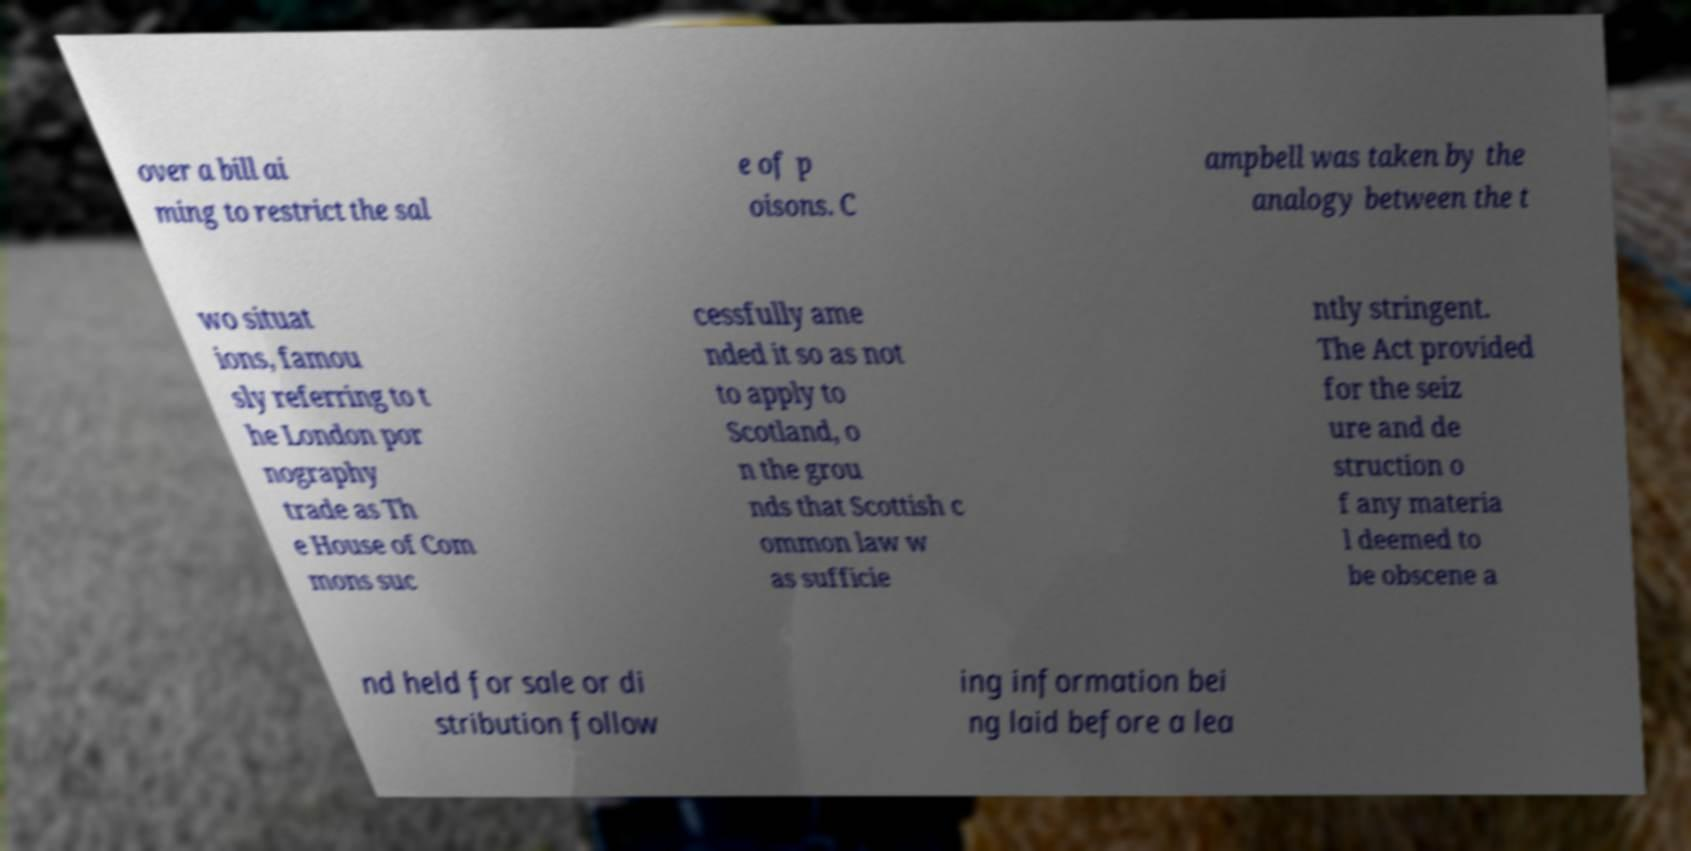For documentation purposes, I need the text within this image transcribed. Could you provide that? over a bill ai ming to restrict the sal e of p oisons. C ampbell was taken by the analogy between the t wo situat ions, famou sly referring to t he London por nography trade as Th e House of Com mons suc cessfully ame nded it so as not to apply to Scotland, o n the grou nds that Scottish c ommon law w as sufficie ntly stringent. The Act provided for the seiz ure and de struction o f any materia l deemed to be obscene a nd held for sale or di stribution follow ing information bei ng laid before a lea 